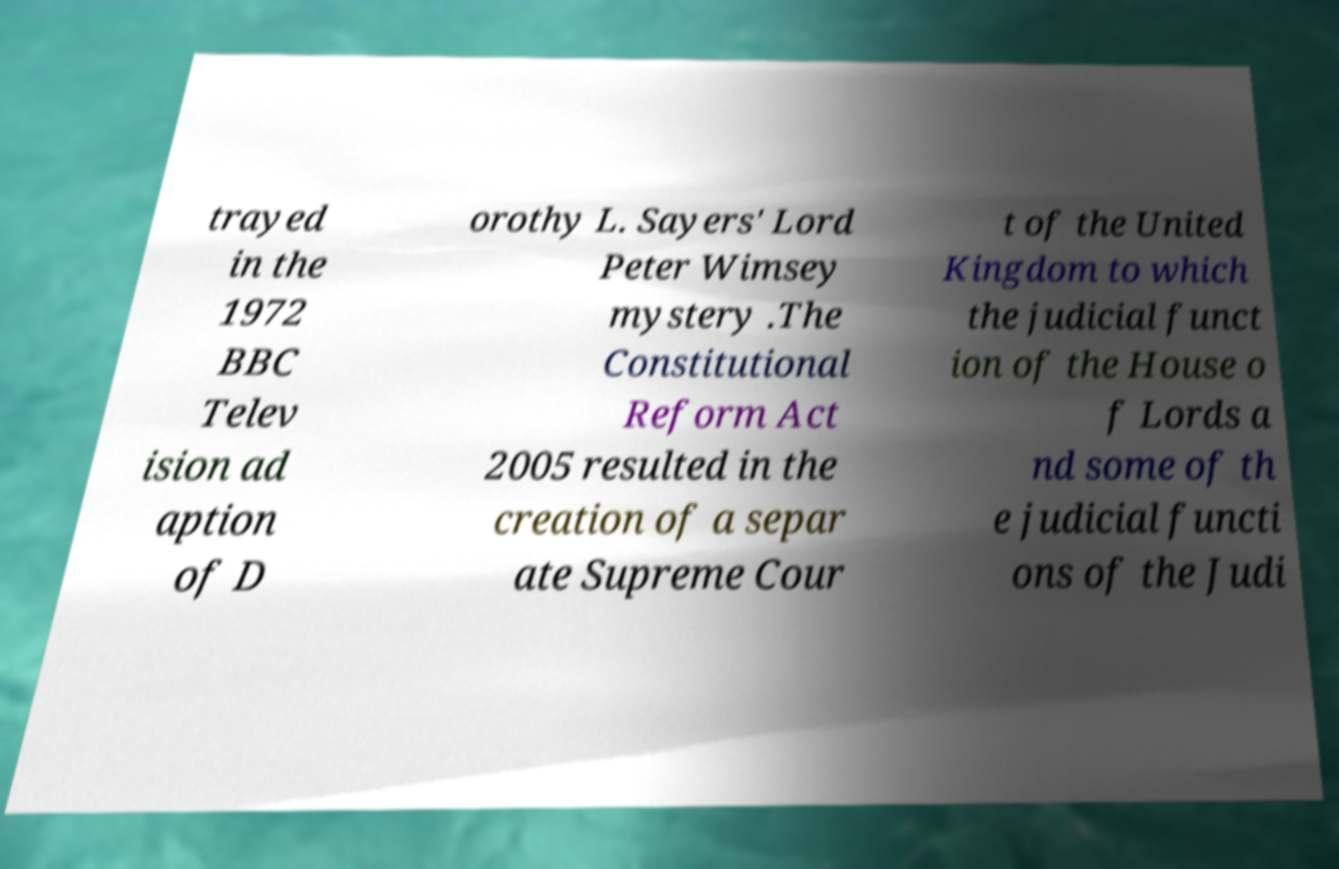I need the written content from this picture converted into text. Can you do that? trayed in the 1972 BBC Telev ision ad aption of D orothy L. Sayers' Lord Peter Wimsey mystery .The Constitutional Reform Act 2005 resulted in the creation of a separ ate Supreme Cour t of the United Kingdom to which the judicial funct ion of the House o f Lords a nd some of th e judicial functi ons of the Judi 